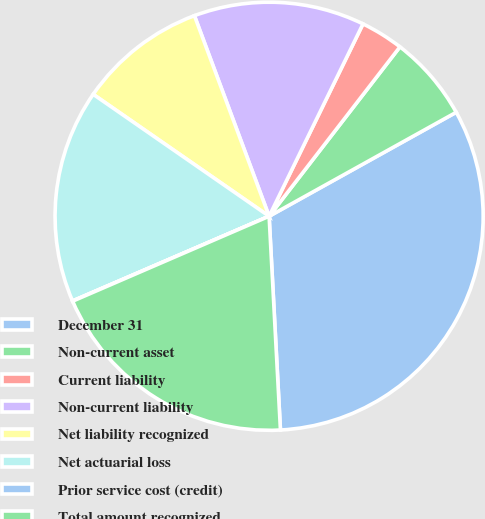Convert chart to OTSL. <chart><loc_0><loc_0><loc_500><loc_500><pie_chart><fcel>December 31<fcel>Non-current asset<fcel>Current liability<fcel>Non-current liability<fcel>Net liability recognized<fcel>Net actuarial loss<fcel>Prior service cost (credit)<fcel>Total amount recognized<nl><fcel>32.23%<fcel>6.46%<fcel>3.24%<fcel>12.9%<fcel>9.68%<fcel>16.12%<fcel>0.02%<fcel>19.35%<nl></chart> 